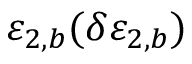<formula> <loc_0><loc_0><loc_500><loc_500>\varepsilon _ { 2 , b } ( \delta \varepsilon _ { 2 , b } )</formula> 